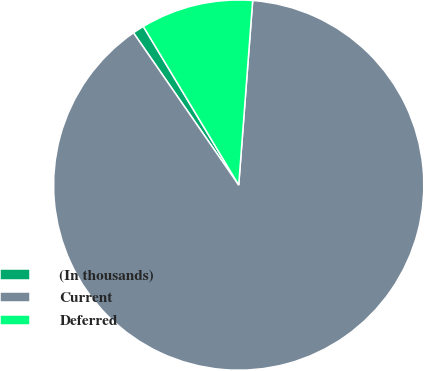Convert chart. <chart><loc_0><loc_0><loc_500><loc_500><pie_chart><fcel>(In thousands)<fcel>Current<fcel>Deferred<nl><fcel>1.01%<fcel>89.17%<fcel>9.82%<nl></chart> 